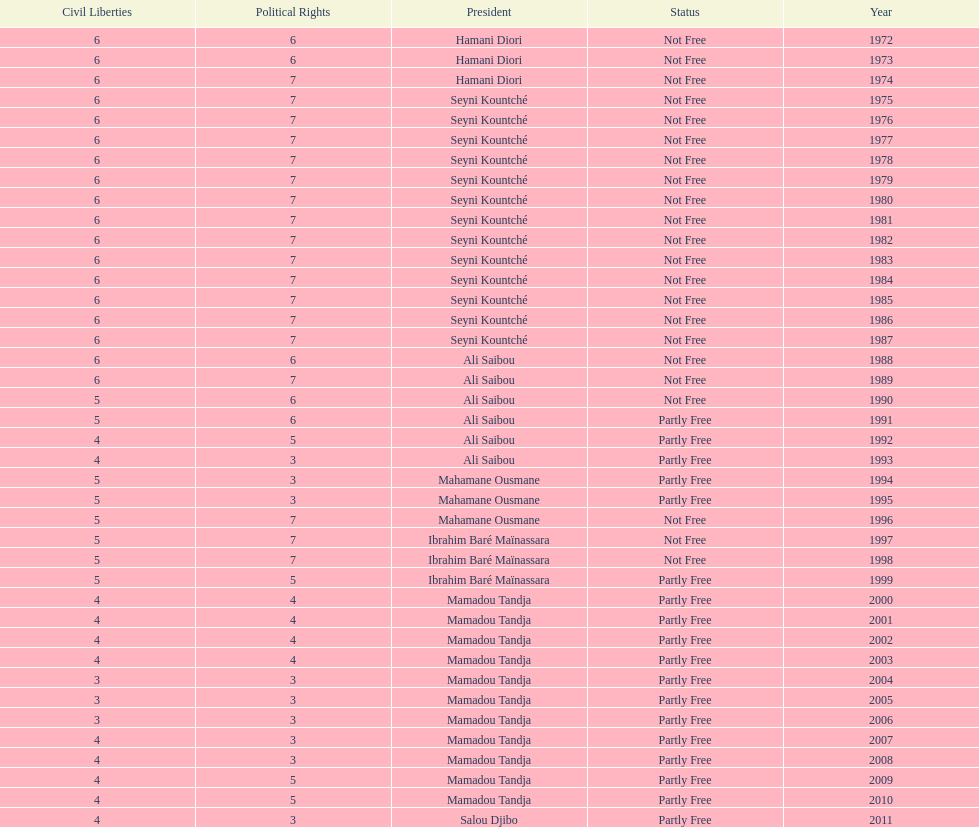Who is the next president listed after hamani diori in the year 1974? Seyni Kountché. 